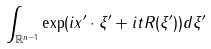Convert formula to latex. <formula><loc_0><loc_0><loc_500><loc_500>\int _ { \mathbb { R } ^ { n - 1 } } \exp ( i x ^ { \prime } \cdot \xi ^ { \prime } + i t R ( \xi ^ { \prime } ) ) d \xi ^ { \prime }</formula> 